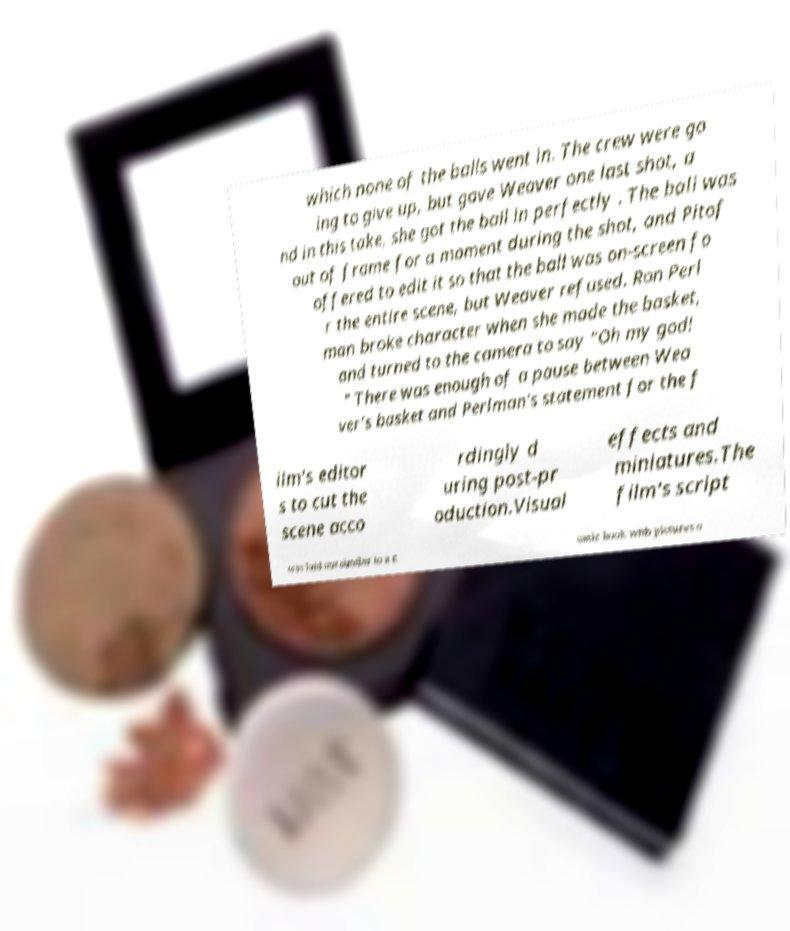There's text embedded in this image that I need extracted. Can you transcribe it verbatim? which none of the balls went in. The crew were go ing to give up, but gave Weaver one last shot, a nd in this take, she got the ball in perfectly . The ball was out of frame for a moment during the shot, and Pitof offered to edit it so that the ball was on-screen fo r the entire scene, but Weaver refused. Ron Perl man broke character when she made the basket, and turned to the camera to say "Oh my god! " There was enough of a pause between Wea ver's basket and Perlman's statement for the f ilm's editor s to cut the scene acco rdingly d uring post-pr oduction.Visual effects and miniatures.The film's script was laid out similar to a c omic book with pictures o 